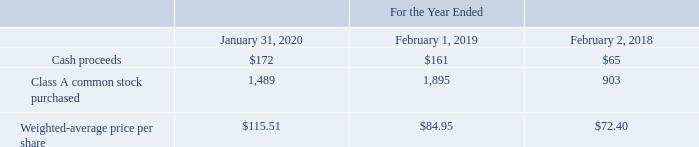VMware and Pivotal Employee Stock Purchase Plans
In June 2007, VMware adopted its 2007 Employee Stock Purchase Plan (the “ESPP”), which is intended to be qualified under Section 423 of the Internal Revenue Code. On June 25, 2019, VMware amended its ESPP to increase the number of shares available for issuance by 9.0 million shares of Class A common stock. As of January 31, 2020, the number of authorized shares under the ESPP was a total of 32.3 million shares. Under the ESPP, eligible VMware employees are granted options to purchase shares at the lower of 85% of the fair market value of the stock at the time of grant or 85% of the fair market value at the time of exercise. The option period is generally twelve months and includes two embedded six-month option periods. Options are exercised at the end of each embedded option period. If the fair market value of the stock is lower on the first day of the second embedded option period than it was at the time of grant, then the twelve-month option period expires and each enrolled participant is granted a new twelve-month option. As of January 31, 2020, 14.3 million shares of VMware Class A common stock were available for issuance under the ESPP.
The following table summarizes ESPP activity for VMware during the periods presented (cash proceeds in millions, shares in thousands):
As of January 31, 2020, $95 million of ESPP withholdings were recorded as a liability in accrued expenses and other on the consolidated balance sheets for the purchase that occurred on February 29, 2020.
Prior to the acquisition of Pivotal, Pivotal granted options to eligible Pivotal employees to purchase shares of its Class A common stock at the lower of 85% of the fair market value of the stock at the time of grant or 85% of the fair market value of the Pivotal stock at the time of exercise. Pivotal’s ESPP activity was not material during the periods presented.
How many authorized shares were there under the ESPP as of  2020? 32.3 million. Which years does the table provide information for ESPP activity for VMware? 2020, 2019, 2018. What were the Cash proceeds in 2020?
Answer scale should be: million. 172. What was the change in cash proceeds between 2018 and 2019?
Answer scale should be: million. 161-65
Answer: 96. What was the change in Class A common stock purchased between 2019 and 2020?
Answer scale should be: thousand. 1,489-1,895
Answer: -406. What was the percentage change in Weighted-average price per share between 2019 and 2020?
Answer scale should be: percent. (115.51-84.95)/84.95
Answer: 35.97. 